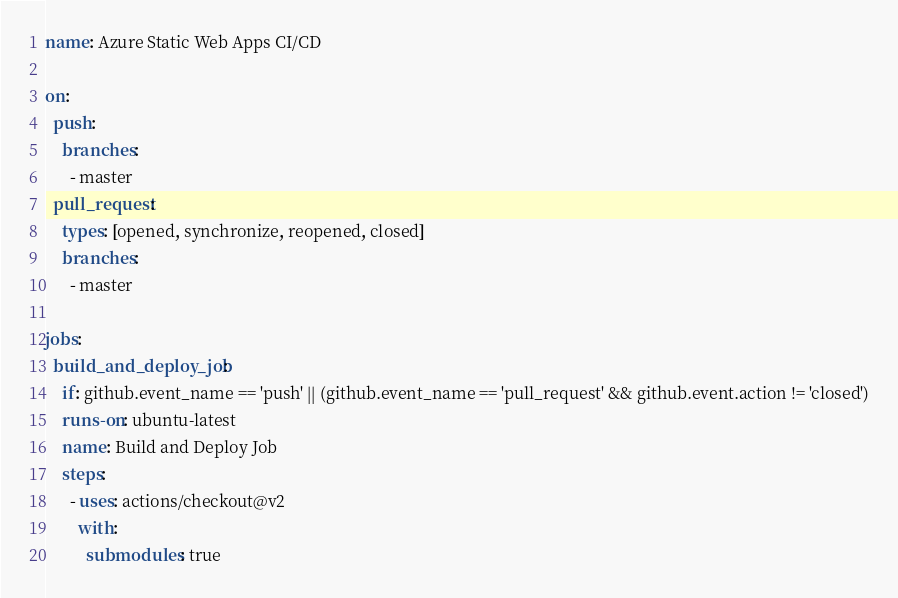Convert code to text. <code><loc_0><loc_0><loc_500><loc_500><_YAML_>name: Azure Static Web Apps CI/CD

on:
  push:
    branches:
      - master
  pull_request:
    types: [opened, synchronize, reopened, closed]
    branches:
      - master

jobs:
  build_and_deploy_job:
    if: github.event_name == 'push' || (github.event_name == 'pull_request' && github.event.action != 'closed')
    runs-on: ubuntu-latest
    name: Build and Deploy Job
    steps:
      - uses: actions/checkout@v2
        with:
          submodules: true</code> 